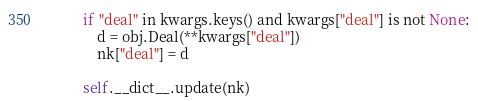Convert code to text. <code><loc_0><loc_0><loc_500><loc_500><_Python_>        if "deal" in kwargs.keys() and kwargs["deal"] is not None:
            d = obj.Deal(**kwargs["deal"])
            nk["deal"] = d

        self.__dict__.update(nk)</code> 